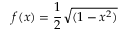Convert formula to latex. <formula><loc_0><loc_0><loc_500><loc_500>f ( x ) = { \frac { 1 } { 2 } } { \sqrt { ( 1 - x ^ { 2 } ) } }</formula> 